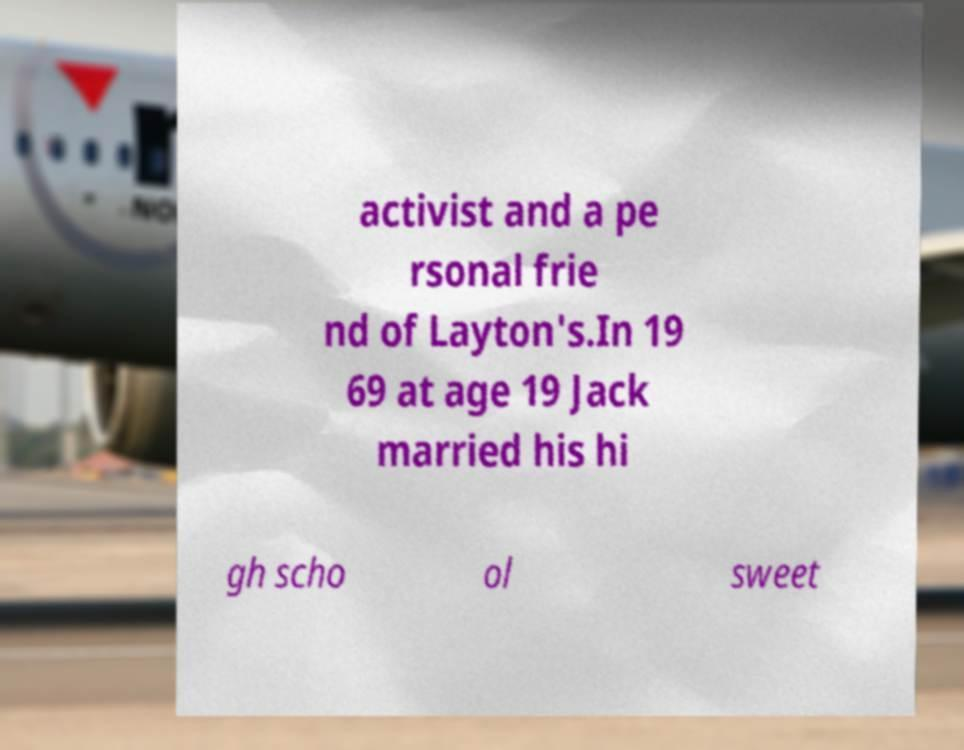For documentation purposes, I need the text within this image transcribed. Could you provide that? activist and a pe rsonal frie nd of Layton's.In 19 69 at age 19 Jack married his hi gh scho ol sweet 